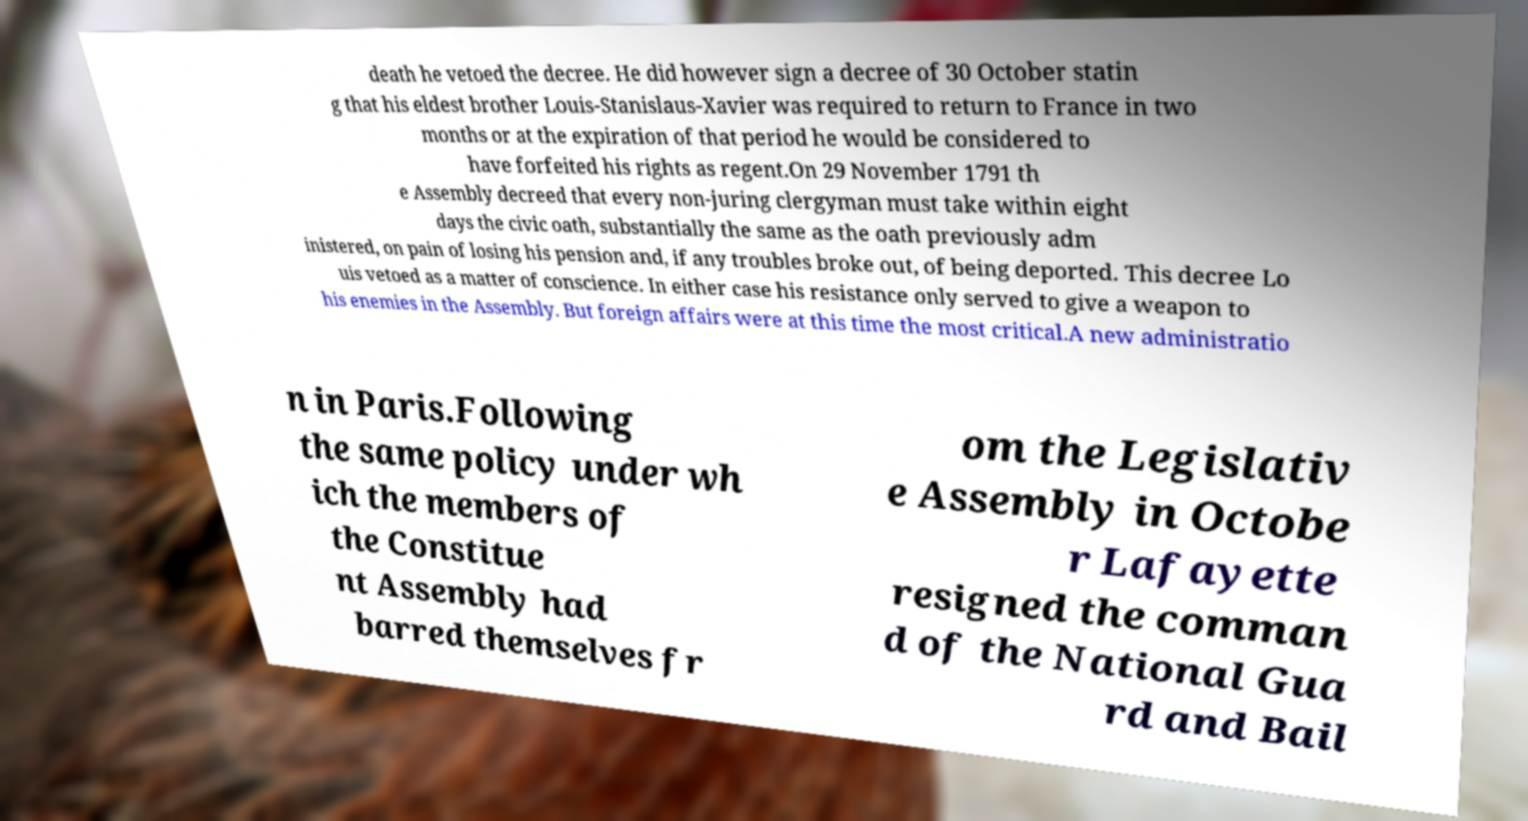There's text embedded in this image that I need extracted. Can you transcribe it verbatim? death he vetoed the decree. He did however sign a decree of 30 October statin g that his eldest brother Louis-Stanislaus-Xavier was required to return to France in two months or at the expiration of that period he would be considered to have forfeited his rights as regent.On 29 November 1791 th e Assembly decreed that every non-juring clergyman must take within eight days the civic oath, substantially the same as the oath previously adm inistered, on pain of losing his pension and, if any troubles broke out, of being deported. This decree Lo uis vetoed as a matter of conscience. In either case his resistance only served to give a weapon to his enemies in the Assembly. But foreign affairs were at this time the most critical.A new administratio n in Paris.Following the same policy under wh ich the members of the Constitue nt Assembly had barred themselves fr om the Legislativ e Assembly in Octobe r Lafayette resigned the comman d of the National Gua rd and Bail 